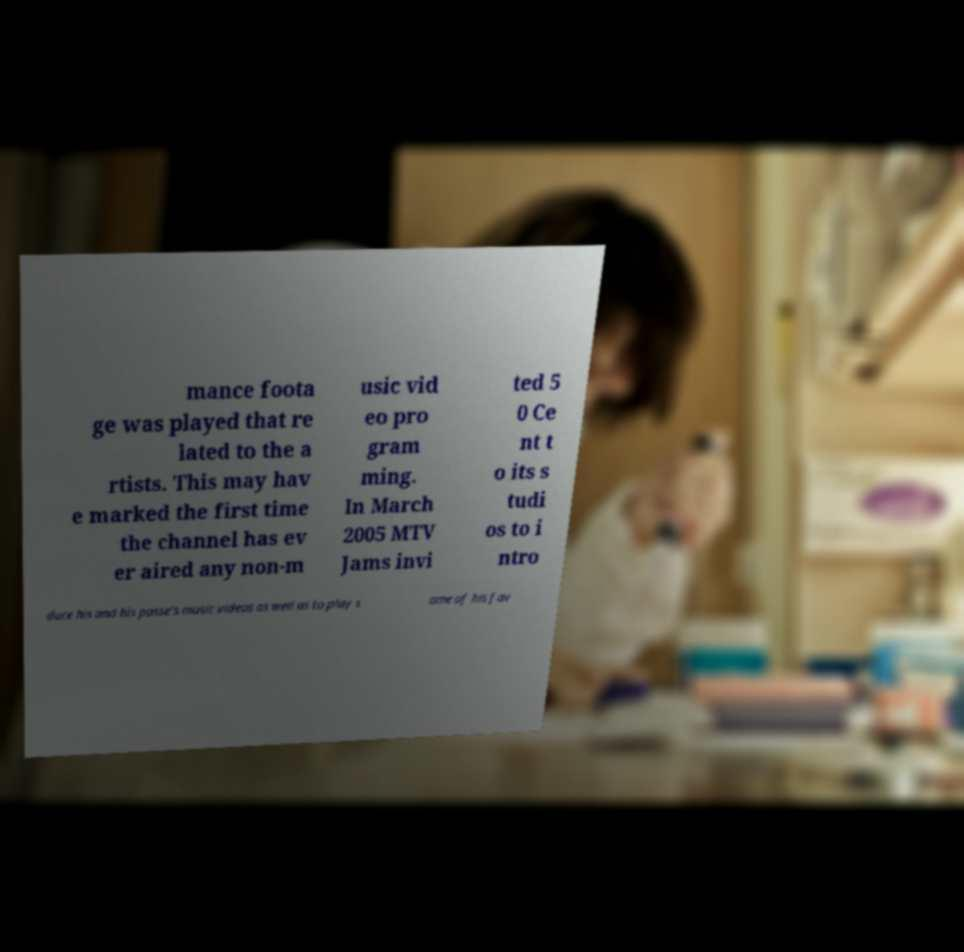Could you assist in decoding the text presented in this image and type it out clearly? mance foota ge was played that re lated to the a rtists. This may hav e marked the first time the channel has ev er aired any non-m usic vid eo pro gram ming. In March 2005 MTV Jams invi ted 5 0 Ce nt t o its s tudi os to i ntro duce his and his posse's music videos as well as to play s ome of his fav 